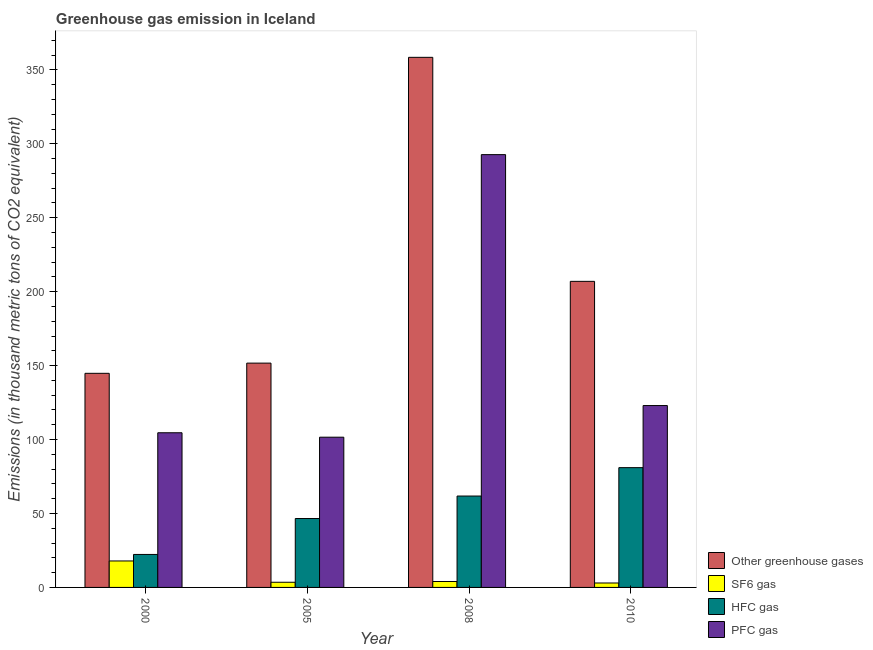How many different coloured bars are there?
Offer a terse response. 4. How many groups of bars are there?
Provide a succinct answer. 4. Are the number of bars per tick equal to the number of legend labels?
Offer a very short reply. Yes. Are the number of bars on each tick of the X-axis equal?
Provide a succinct answer. Yes. What is the label of the 1st group of bars from the left?
Keep it short and to the point. 2000. In how many cases, is the number of bars for a given year not equal to the number of legend labels?
Provide a succinct answer. 0. What is the emission of hfc gas in 2005?
Your answer should be compact. 46.6. Across all years, what is the maximum emission of greenhouse gases?
Provide a succinct answer. 358.5. Across all years, what is the minimum emission of greenhouse gases?
Keep it short and to the point. 144.8. What is the total emission of hfc gas in the graph?
Offer a terse response. 211.7. What is the difference between the emission of hfc gas in 2000 and that in 2008?
Your answer should be very brief. -39.5. What is the difference between the emission of sf6 gas in 2010 and the emission of hfc gas in 2000?
Provide a succinct answer. -14.9. In how many years, is the emission of greenhouse gases greater than 160 thousand metric tons?
Give a very brief answer. 2. What is the ratio of the emission of pfc gas in 2000 to that in 2010?
Offer a very short reply. 0.85. Is the difference between the emission of greenhouse gases in 2000 and 2010 greater than the difference between the emission of hfc gas in 2000 and 2010?
Keep it short and to the point. No. What is the difference between the highest and the second highest emission of greenhouse gases?
Make the answer very short. 151.5. What is the difference between the highest and the lowest emission of pfc gas?
Your answer should be compact. 191.1. Is the sum of the emission of sf6 gas in 2005 and 2010 greater than the maximum emission of greenhouse gases across all years?
Your answer should be very brief. No. What does the 4th bar from the left in 2010 represents?
Your answer should be compact. PFC gas. What does the 3rd bar from the right in 2005 represents?
Offer a very short reply. SF6 gas. Is it the case that in every year, the sum of the emission of greenhouse gases and emission of sf6 gas is greater than the emission of hfc gas?
Keep it short and to the point. Yes. How many years are there in the graph?
Give a very brief answer. 4. What is the difference between two consecutive major ticks on the Y-axis?
Your response must be concise. 50. Are the values on the major ticks of Y-axis written in scientific E-notation?
Provide a short and direct response. No. Does the graph contain grids?
Make the answer very short. No. Where does the legend appear in the graph?
Your answer should be compact. Bottom right. How many legend labels are there?
Your answer should be very brief. 4. How are the legend labels stacked?
Offer a very short reply. Vertical. What is the title of the graph?
Give a very brief answer. Greenhouse gas emission in Iceland. Does "Subsidies and Transfers" appear as one of the legend labels in the graph?
Give a very brief answer. No. What is the label or title of the Y-axis?
Keep it short and to the point. Emissions (in thousand metric tons of CO2 equivalent). What is the Emissions (in thousand metric tons of CO2 equivalent) of Other greenhouse gases in 2000?
Provide a short and direct response. 144.8. What is the Emissions (in thousand metric tons of CO2 equivalent) of SF6 gas in 2000?
Provide a short and direct response. 17.9. What is the Emissions (in thousand metric tons of CO2 equivalent) in HFC gas in 2000?
Ensure brevity in your answer.  22.3. What is the Emissions (in thousand metric tons of CO2 equivalent) in PFC gas in 2000?
Provide a succinct answer. 104.6. What is the Emissions (in thousand metric tons of CO2 equivalent) in Other greenhouse gases in 2005?
Offer a terse response. 151.7. What is the Emissions (in thousand metric tons of CO2 equivalent) in SF6 gas in 2005?
Make the answer very short. 3.5. What is the Emissions (in thousand metric tons of CO2 equivalent) in HFC gas in 2005?
Give a very brief answer. 46.6. What is the Emissions (in thousand metric tons of CO2 equivalent) in PFC gas in 2005?
Provide a short and direct response. 101.6. What is the Emissions (in thousand metric tons of CO2 equivalent) of Other greenhouse gases in 2008?
Your answer should be compact. 358.5. What is the Emissions (in thousand metric tons of CO2 equivalent) in HFC gas in 2008?
Offer a terse response. 61.8. What is the Emissions (in thousand metric tons of CO2 equivalent) in PFC gas in 2008?
Offer a terse response. 292.7. What is the Emissions (in thousand metric tons of CO2 equivalent) in Other greenhouse gases in 2010?
Keep it short and to the point. 207. What is the Emissions (in thousand metric tons of CO2 equivalent) in SF6 gas in 2010?
Ensure brevity in your answer.  3. What is the Emissions (in thousand metric tons of CO2 equivalent) in PFC gas in 2010?
Ensure brevity in your answer.  123. Across all years, what is the maximum Emissions (in thousand metric tons of CO2 equivalent) of Other greenhouse gases?
Offer a terse response. 358.5. Across all years, what is the maximum Emissions (in thousand metric tons of CO2 equivalent) in HFC gas?
Your answer should be compact. 81. Across all years, what is the maximum Emissions (in thousand metric tons of CO2 equivalent) of PFC gas?
Provide a succinct answer. 292.7. Across all years, what is the minimum Emissions (in thousand metric tons of CO2 equivalent) of Other greenhouse gases?
Offer a very short reply. 144.8. Across all years, what is the minimum Emissions (in thousand metric tons of CO2 equivalent) of HFC gas?
Provide a succinct answer. 22.3. Across all years, what is the minimum Emissions (in thousand metric tons of CO2 equivalent) of PFC gas?
Your response must be concise. 101.6. What is the total Emissions (in thousand metric tons of CO2 equivalent) of Other greenhouse gases in the graph?
Provide a succinct answer. 862. What is the total Emissions (in thousand metric tons of CO2 equivalent) in SF6 gas in the graph?
Ensure brevity in your answer.  28.4. What is the total Emissions (in thousand metric tons of CO2 equivalent) in HFC gas in the graph?
Provide a short and direct response. 211.7. What is the total Emissions (in thousand metric tons of CO2 equivalent) of PFC gas in the graph?
Make the answer very short. 621.9. What is the difference between the Emissions (in thousand metric tons of CO2 equivalent) in Other greenhouse gases in 2000 and that in 2005?
Ensure brevity in your answer.  -6.9. What is the difference between the Emissions (in thousand metric tons of CO2 equivalent) in HFC gas in 2000 and that in 2005?
Your answer should be compact. -24.3. What is the difference between the Emissions (in thousand metric tons of CO2 equivalent) of PFC gas in 2000 and that in 2005?
Keep it short and to the point. 3. What is the difference between the Emissions (in thousand metric tons of CO2 equivalent) in Other greenhouse gases in 2000 and that in 2008?
Ensure brevity in your answer.  -213.7. What is the difference between the Emissions (in thousand metric tons of CO2 equivalent) in HFC gas in 2000 and that in 2008?
Provide a short and direct response. -39.5. What is the difference between the Emissions (in thousand metric tons of CO2 equivalent) in PFC gas in 2000 and that in 2008?
Offer a terse response. -188.1. What is the difference between the Emissions (in thousand metric tons of CO2 equivalent) in Other greenhouse gases in 2000 and that in 2010?
Your answer should be compact. -62.2. What is the difference between the Emissions (in thousand metric tons of CO2 equivalent) of HFC gas in 2000 and that in 2010?
Offer a terse response. -58.7. What is the difference between the Emissions (in thousand metric tons of CO2 equivalent) in PFC gas in 2000 and that in 2010?
Your answer should be compact. -18.4. What is the difference between the Emissions (in thousand metric tons of CO2 equivalent) of Other greenhouse gases in 2005 and that in 2008?
Make the answer very short. -206.8. What is the difference between the Emissions (in thousand metric tons of CO2 equivalent) in SF6 gas in 2005 and that in 2008?
Offer a terse response. -0.5. What is the difference between the Emissions (in thousand metric tons of CO2 equivalent) in HFC gas in 2005 and that in 2008?
Your response must be concise. -15.2. What is the difference between the Emissions (in thousand metric tons of CO2 equivalent) in PFC gas in 2005 and that in 2008?
Offer a very short reply. -191.1. What is the difference between the Emissions (in thousand metric tons of CO2 equivalent) in Other greenhouse gases in 2005 and that in 2010?
Ensure brevity in your answer.  -55.3. What is the difference between the Emissions (in thousand metric tons of CO2 equivalent) in HFC gas in 2005 and that in 2010?
Ensure brevity in your answer.  -34.4. What is the difference between the Emissions (in thousand metric tons of CO2 equivalent) of PFC gas in 2005 and that in 2010?
Your answer should be very brief. -21.4. What is the difference between the Emissions (in thousand metric tons of CO2 equivalent) of Other greenhouse gases in 2008 and that in 2010?
Provide a succinct answer. 151.5. What is the difference between the Emissions (in thousand metric tons of CO2 equivalent) of HFC gas in 2008 and that in 2010?
Make the answer very short. -19.2. What is the difference between the Emissions (in thousand metric tons of CO2 equivalent) of PFC gas in 2008 and that in 2010?
Offer a very short reply. 169.7. What is the difference between the Emissions (in thousand metric tons of CO2 equivalent) in Other greenhouse gases in 2000 and the Emissions (in thousand metric tons of CO2 equivalent) in SF6 gas in 2005?
Your response must be concise. 141.3. What is the difference between the Emissions (in thousand metric tons of CO2 equivalent) in Other greenhouse gases in 2000 and the Emissions (in thousand metric tons of CO2 equivalent) in HFC gas in 2005?
Keep it short and to the point. 98.2. What is the difference between the Emissions (in thousand metric tons of CO2 equivalent) of Other greenhouse gases in 2000 and the Emissions (in thousand metric tons of CO2 equivalent) of PFC gas in 2005?
Offer a very short reply. 43.2. What is the difference between the Emissions (in thousand metric tons of CO2 equivalent) of SF6 gas in 2000 and the Emissions (in thousand metric tons of CO2 equivalent) of HFC gas in 2005?
Provide a succinct answer. -28.7. What is the difference between the Emissions (in thousand metric tons of CO2 equivalent) in SF6 gas in 2000 and the Emissions (in thousand metric tons of CO2 equivalent) in PFC gas in 2005?
Your answer should be very brief. -83.7. What is the difference between the Emissions (in thousand metric tons of CO2 equivalent) in HFC gas in 2000 and the Emissions (in thousand metric tons of CO2 equivalent) in PFC gas in 2005?
Your answer should be compact. -79.3. What is the difference between the Emissions (in thousand metric tons of CO2 equivalent) in Other greenhouse gases in 2000 and the Emissions (in thousand metric tons of CO2 equivalent) in SF6 gas in 2008?
Your answer should be compact. 140.8. What is the difference between the Emissions (in thousand metric tons of CO2 equivalent) of Other greenhouse gases in 2000 and the Emissions (in thousand metric tons of CO2 equivalent) of PFC gas in 2008?
Make the answer very short. -147.9. What is the difference between the Emissions (in thousand metric tons of CO2 equivalent) in SF6 gas in 2000 and the Emissions (in thousand metric tons of CO2 equivalent) in HFC gas in 2008?
Give a very brief answer. -43.9. What is the difference between the Emissions (in thousand metric tons of CO2 equivalent) in SF6 gas in 2000 and the Emissions (in thousand metric tons of CO2 equivalent) in PFC gas in 2008?
Your answer should be very brief. -274.8. What is the difference between the Emissions (in thousand metric tons of CO2 equivalent) of HFC gas in 2000 and the Emissions (in thousand metric tons of CO2 equivalent) of PFC gas in 2008?
Provide a succinct answer. -270.4. What is the difference between the Emissions (in thousand metric tons of CO2 equivalent) in Other greenhouse gases in 2000 and the Emissions (in thousand metric tons of CO2 equivalent) in SF6 gas in 2010?
Provide a short and direct response. 141.8. What is the difference between the Emissions (in thousand metric tons of CO2 equivalent) of Other greenhouse gases in 2000 and the Emissions (in thousand metric tons of CO2 equivalent) of HFC gas in 2010?
Offer a terse response. 63.8. What is the difference between the Emissions (in thousand metric tons of CO2 equivalent) of Other greenhouse gases in 2000 and the Emissions (in thousand metric tons of CO2 equivalent) of PFC gas in 2010?
Make the answer very short. 21.8. What is the difference between the Emissions (in thousand metric tons of CO2 equivalent) in SF6 gas in 2000 and the Emissions (in thousand metric tons of CO2 equivalent) in HFC gas in 2010?
Keep it short and to the point. -63.1. What is the difference between the Emissions (in thousand metric tons of CO2 equivalent) of SF6 gas in 2000 and the Emissions (in thousand metric tons of CO2 equivalent) of PFC gas in 2010?
Offer a terse response. -105.1. What is the difference between the Emissions (in thousand metric tons of CO2 equivalent) in HFC gas in 2000 and the Emissions (in thousand metric tons of CO2 equivalent) in PFC gas in 2010?
Keep it short and to the point. -100.7. What is the difference between the Emissions (in thousand metric tons of CO2 equivalent) of Other greenhouse gases in 2005 and the Emissions (in thousand metric tons of CO2 equivalent) of SF6 gas in 2008?
Ensure brevity in your answer.  147.7. What is the difference between the Emissions (in thousand metric tons of CO2 equivalent) of Other greenhouse gases in 2005 and the Emissions (in thousand metric tons of CO2 equivalent) of HFC gas in 2008?
Keep it short and to the point. 89.9. What is the difference between the Emissions (in thousand metric tons of CO2 equivalent) of Other greenhouse gases in 2005 and the Emissions (in thousand metric tons of CO2 equivalent) of PFC gas in 2008?
Make the answer very short. -141. What is the difference between the Emissions (in thousand metric tons of CO2 equivalent) of SF6 gas in 2005 and the Emissions (in thousand metric tons of CO2 equivalent) of HFC gas in 2008?
Your answer should be very brief. -58.3. What is the difference between the Emissions (in thousand metric tons of CO2 equivalent) of SF6 gas in 2005 and the Emissions (in thousand metric tons of CO2 equivalent) of PFC gas in 2008?
Make the answer very short. -289.2. What is the difference between the Emissions (in thousand metric tons of CO2 equivalent) in HFC gas in 2005 and the Emissions (in thousand metric tons of CO2 equivalent) in PFC gas in 2008?
Make the answer very short. -246.1. What is the difference between the Emissions (in thousand metric tons of CO2 equivalent) in Other greenhouse gases in 2005 and the Emissions (in thousand metric tons of CO2 equivalent) in SF6 gas in 2010?
Your response must be concise. 148.7. What is the difference between the Emissions (in thousand metric tons of CO2 equivalent) of Other greenhouse gases in 2005 and the Emissions (in thousand metric tons of CO2 equivalent) of HFC gas in 2010?
Your response must be concise. 70.7. What is the difference between the Emissions (in thousand metric tons of CO2 equivalent) in Other greenhouse gases in 2005 and the Emissions (in thousand metric tons of CO2 equivalent) in PFC gas in 2010?
Ensure brevity in your answer.  28.7. What is the difference between the Emissions (in thousand metric tons of CO2 equivalent) of SF6 gas in 2005 and the Emissions (in thousand metric tons of CO2 equivalent) of HFC gas in 2010?
Provide a succinct answer. -77.5. What is the difference between the Emissions (in thousand metric tons of CO2 equivalent) in SF6 gas in 2005 and the Emissions (in thousand metric tons of CO2 equivalent) in PFC gas in 2010?
Offer a terse response. -119.5. What is the difference between the Emissions (in thousand metric tons of CO2 equivalent) in HFC gas in 2005 and the Emissions (in thousand metric tons of CO2 equivalent) in PFC gas in 2010?
Your answer should be very brief. -76.4. What is the difference between the Emissions (in thousand metric tons of CO2 equivalent) in Other greenhouse gases in 2008 and the Emissions (in thousand metric tons of CO2 equivalent) in SF6 gas in 2010?
Make the answer very short. 355.5. What is the difference between the Emissions (in thousand metric tons of CO2 equivalent) of Other greenhouse gases in 2008 and the Emissions (in thousand metric tons of CO2 equivalent) of HFC gas in 2010?
Ensure brevity in your answer.  277.5. What is the difference between the Emissions (in thousand metric tons of CO2 equivalent) in Other greenhouse gases in 2008 and the Emissions (in thousand metric tons of CO2 equivalent) in PFC gas in 2010?
Your answer should be very brief. 235.5. What is the difference between the Emissions (in thousand metric tons of CO2 equivalent) in SF6 gas in 2008 and the Emissions (in thousand metric tons of CO2 equivalent) in HFC gas in 2010?
Make the answer very short. -77. What is the difference between the Emissions (in thousand metric tons of CO2 equivalent) in SF6 gas in 2008 and the Emissions (in thousand metric tons of CO2 equivalent) in PFC gas in 2010?
Give a very brief answer. -119. What is the difference between the Emissions (in thousand metric tons of CO2 equivalent) of HFC gas in 2008 and the Emissions (in thousand metric tons of CO2 equivalent) of PFC gas in 2010?
Your answer should be compact. -61.2. What is the average Emissions (in thousand metric tons of CO2 equivalent) of Other greenhouse gases per year?
Keep it short and to the point. 215.5. What is the average Emissions (in thousand metric tons of CO2 equivalent) in SF6 gas per year?
Your answer should be compact. 7.1. What is the average Emissions (in thousand metric tons of CO2 equivalent) of HFC gas per year?
Offer a terse response. 52.92. What is the average Emissions (in thousand metric tons of CO2 equivalent) of PFC gas per year?
Your response must be concise. 155.47. In the year 2000, what is the difference between the Emissions (in thousand metric tons of CO2 equivalent) of Other greenhouse gases and Emissions (in thousand metric tons of CO2 equivalent) of SF6 gas?
Your response must be concise. 126.9. In the year 2000, what is the difference between the Emissions (in thousand metric tons of CO2 equivalent) of Other greenhouse gases and Emissions (in thousand metric tons of CO2 equivalent) of HFC gas?
Offer a very short reply. 122.5. In the year 2000, what is the difference between the Emissions (in thousand metric tons of CO2 equivalent) in Other greenhouse gases and Emissions (in thousand metric tons of CO2 equivalent) in PFC gas?
Ensure brevity in your answer.  40.2. In the year 2000, what is the difference between the Emissions (in thousand metric tons of CO2 equivalent) in SF6 gas and Emissions (in thousand metric tons of CO2 equivalent) in PFC gas?
Your answer should be compact. -86.7. In the year 2000, what is the difference between the Emissions (in thousand metric tons of CO2 equivalent) of HFC gas and Emissions (in thousand metric tons of CO2 equivalent) of PFC gas?
Keep it short and to the point. -82.3. In the year 2005, what is the difference between the Emissions (in thousand metric tons of CO2 equivalent) of Other greenhouse gases and Emissions (in thousand metric tons of CO2 equivalent) of SF6 gas?
Ensure brevity in your answer.  148.2. In the year 2005, what is the difference between the Emissions (in thousand metric tons of CO2 equivalent) in Other greenhouse gases and Emissions (in thousand metric tons of CO2 equivalent) in HFC gas?
Offer a very short reply. 105.1. In the year 2005, what is the difference between the Emissions (in thousand metric tons of CO2 equivalent) in Other greenhouse gases and Emissions (in thousand metric tons of CO2 equivalent) in PFC gas?
Give a very brief answer. 50.1. In the year 2005, what is the difference between the Emissions (in thousand metric tons of CO2 equivalent) of SF6 gas and Emissions (in thousand metric tons of CO2 equivalent) of HFC gas?
Keep it short and to the point. -43.1. In the year 2005, what is the difference between the Emissions (in thousand metric tons of CO2 equivalent) of SF6 gas and Emissions (in thousand metric tons of CO2 equivalent) of PFC gas?
Your answer should be very brief. -98.1. In the year 2005, what is the difference between the Emissions (in thousand metric tons of CO2 equivalent) of HFC gas and Emissions (in thousand metric tons of CO2 equivalent) of PFC gas?
Your answer should be very brief. -55. In the year 2008, what is the difference between the Emissions (in thousand metric tons of CO2 equivalent) of Other greenhouse gases and Emissions (in thousand metric tons of CO2 equivalent) of SF6 gas?
Your answer should be compact. 354.5. In the year 2008, what is the difference between the Emissions (in thousand metric tons of CO2 equivalent) of Other greenhouse gases and Emissions (in thousand metric tons of CO2 equivalent) of HFC gas?
Ensure brevity in your answer.  296.7. In the year 2008, what is the difference between the Emissions (in thousand metric tons of CO2 equivalent) of Other greenhouse gases and Emissions (in thousand metric tons of CO2 equivalent) of PFC gas?
Give a very brief answer. 65.8. In the year 2008, what is the difference between the Emissions (in thousand metric tons of CO2 equivalent) in SF6 gas and Emissions (in thousand metric tons of CO2 equivalent) in HFC gas?
Your answer should be compact. -57.8. In the year 2008, what is the difference between the Emissions (in thousand metric tons of CO2 equivalent) of SF6 gas and Emissions (in thousand metric tons of CO2 equivalent) of PFC gas?
Your answer should be very brief. -288.7. In the year 2008, what is the difference between the Emissions (in thousand metric tons of CO2 equivalent) in HFC gas and Emissions (in thousand metric tons of CO2 equivalent) in PFC gas?
Provide a short and direct response. -230.9. In the year 2010, what is the difference between the Emissions (in thousand metric tons of CO2 equivalent) of Other greenhouse gases and Emissions (in thousand metric tons of CO2 equivalent) of SF6 gas?
Offer a very short reply. 204. In the year 2010, what is the difference between the Emissions (in thousand metric tons of CO2 equivalent) of Other greenhouse gases and Emissions (in thousand metric tons of CO2 equivalent) of HFC gas?
Your response must be concise. 126. In the year 2010, what is the difference between the Emissions (in thousand metric tons of CO2 equivalent) in SF6 gas and Emissions (in thousand metric tons of CO2 equivalent) in HFC gas?
Make the answer very short. -78. In the year 2010, what is the difference between the Emissions (in thousand metric tons of CO2 equivalent) of SF6 gas and Emissions (in thousand metric tons of CO2 equivalent) of PFC gas?
Make the answer very short. -120. In the year 2010, what is the difference between the Emissions (in thousand metric tons of CO2 equivalent) of HFC gas and Emissions (in thousand metric tons of CO2 equivalent) of PFC gas?
Your response must be concise. -42. What is the ratio of the Emissions (in thousand metric tons of CO2 equivalent) in Other greenhouse gases in 2000 to that in 2005?
Make the answer very short. 0.95. What is the ratio of the Emissions (in thousand metric tons of CO2 equivalent) in SF6 gas in 2000 to that in 2005?
Offer a terse response. 5.11. What is the ratio of the Emissions (in thousand metric tons of CO2 equivalent) in HFC gas in 2000 to that in 2005?
Give a very brief answer. 0.48. What is the ratio of the Emissions (in thousand metric tons of CO2 equivalent) in PFC gas in 2000 to that in 2005?
Your answer should be very brief. 1.03. What is the ratio of the Emissions (in thousand metric tons of CO2 equivalent) of Other greenhouse gases in 2000 to that in 2008?
Your answer should be compact. 0.4. What is the ratio of the Emissions (in thousand metric tons of CO2 equivalent) of SF6 gas in 2000 to that in 2008?
Your answer should be very brief. 4.47. What is the ratio of the Emissions (in thousand metric tons of CO2 equivalent) of HFC gas in 2000 to that in 2008?
Your answer should be compact. 0.36. What is the ratio of the Emissions (in thousand metric tons of CO2 equivalent) in PFC gas in 2000 to that in 2008?
Give a very brief answer. 0.36. What is the ratio of the Emissions (in thousand metric tons of CO2 equivalent) of Other greenhouse gases in 2000 to that in 2010?
Ensure brevity in your answer.  0.7. What is the ratio of the Emissions (in thousand metric tons of CO2 equivalent) of SF6 gas in 2000 to that in 2010?
Ensure brevity in your answer.  5.97. What is the ratio of the Emissions (in thousand metric tons of CO2 equivalent) of HFC gas in 2000 to that in 2010?
Your answer should be compact. 0.28. What is the ratio of the Emissions (in thousand metric tons of CO2 equivalent) of PFC gas in 2000 to that in 2010?
Ensure brevity in your answer.  0.85. What is the ratio of the Emissions (in thousand metric tons of CO2 equivalent) in Other greenhouse gases in 2005 to that in 2008?
Your answer should be very brief. 0.42. What is the ratio of the Emissions (in thousand metric tons of CO2 equivalent) of HFC gas in 2005 to that in 2008?
Your answer should be very brief. 0.75. What is the ratio of the Emissions (in thousand metric tons of CO2 equivalent) in PFC gas in 2005 to that in 2008?
Keep it short and to the point. 0.35. What is the ratio of the Emissions (in thousand metric tons of CO2 equivalent) in Other greenhouse gases in 2005 to that in 2010?
Your answer should be compact. 0.73. What is the ratio of the Emissions (in thousand metric tons of CO2 equivalent) of SF6 gas in 2005 to that in 2010?
Your answer should be very brief. 1.17. What is the ratio of the Emissions (in thousand metric tons of CO2 equivalent) of HFC gas in 2005 to that in 2010?
Ensure brevity in your answer.  0.58. What is the ratio of the Emissions (in thousand metric tons of CO2 equivalent) of PFC gas in 2005 to that in 2010?
Your answer should be compact. 0.83. What is the ratio of the Emissions (in thousand metric tons of CO2 equivalent) of Other greenhouse gases in 2008 to that in 2010?
Your answer should be compact. 1.73. What is the ratio of the Emissions (in thousand metric tons of CO2 equivalent) of HFC gas in 2008 to that in 2010?
Ensure brevity in your answer.  0.76. What is the ratio of the Emissions (in thousand metric tons of CO2 equivalent) of PFC gas in 2008 to that in 2010?
Keep it short and to the point. 2.38. What is the difference between the highest and the second highest Emissions (in thousand metric tons of CO2 equivalent) of Other greenhouse gases?
Give a very brief answer. 151.5. What is the difference between the highest and the second highest Emissions (in thousand metric tons of CO2 equivalent) in PFC gas?
Keep it short and to the point. 169.7. What is the difference between the highest and the lowest Emissions (in thousand metric tons of CO2 equivalent) of Other greenhouse gases?
Provide a succinct answer. 213.7. What is the difference between the highest and the lowest Emissions (in thousand metric tons of CO2 equivalent) in HFC gas?
Provide a short and direct response. 58.7. What is the difference between the highest and the lowest Emissions (in thousand metric tons of CO2 equivalent) of PFC gas?
Make the answer very short. 191.1. 